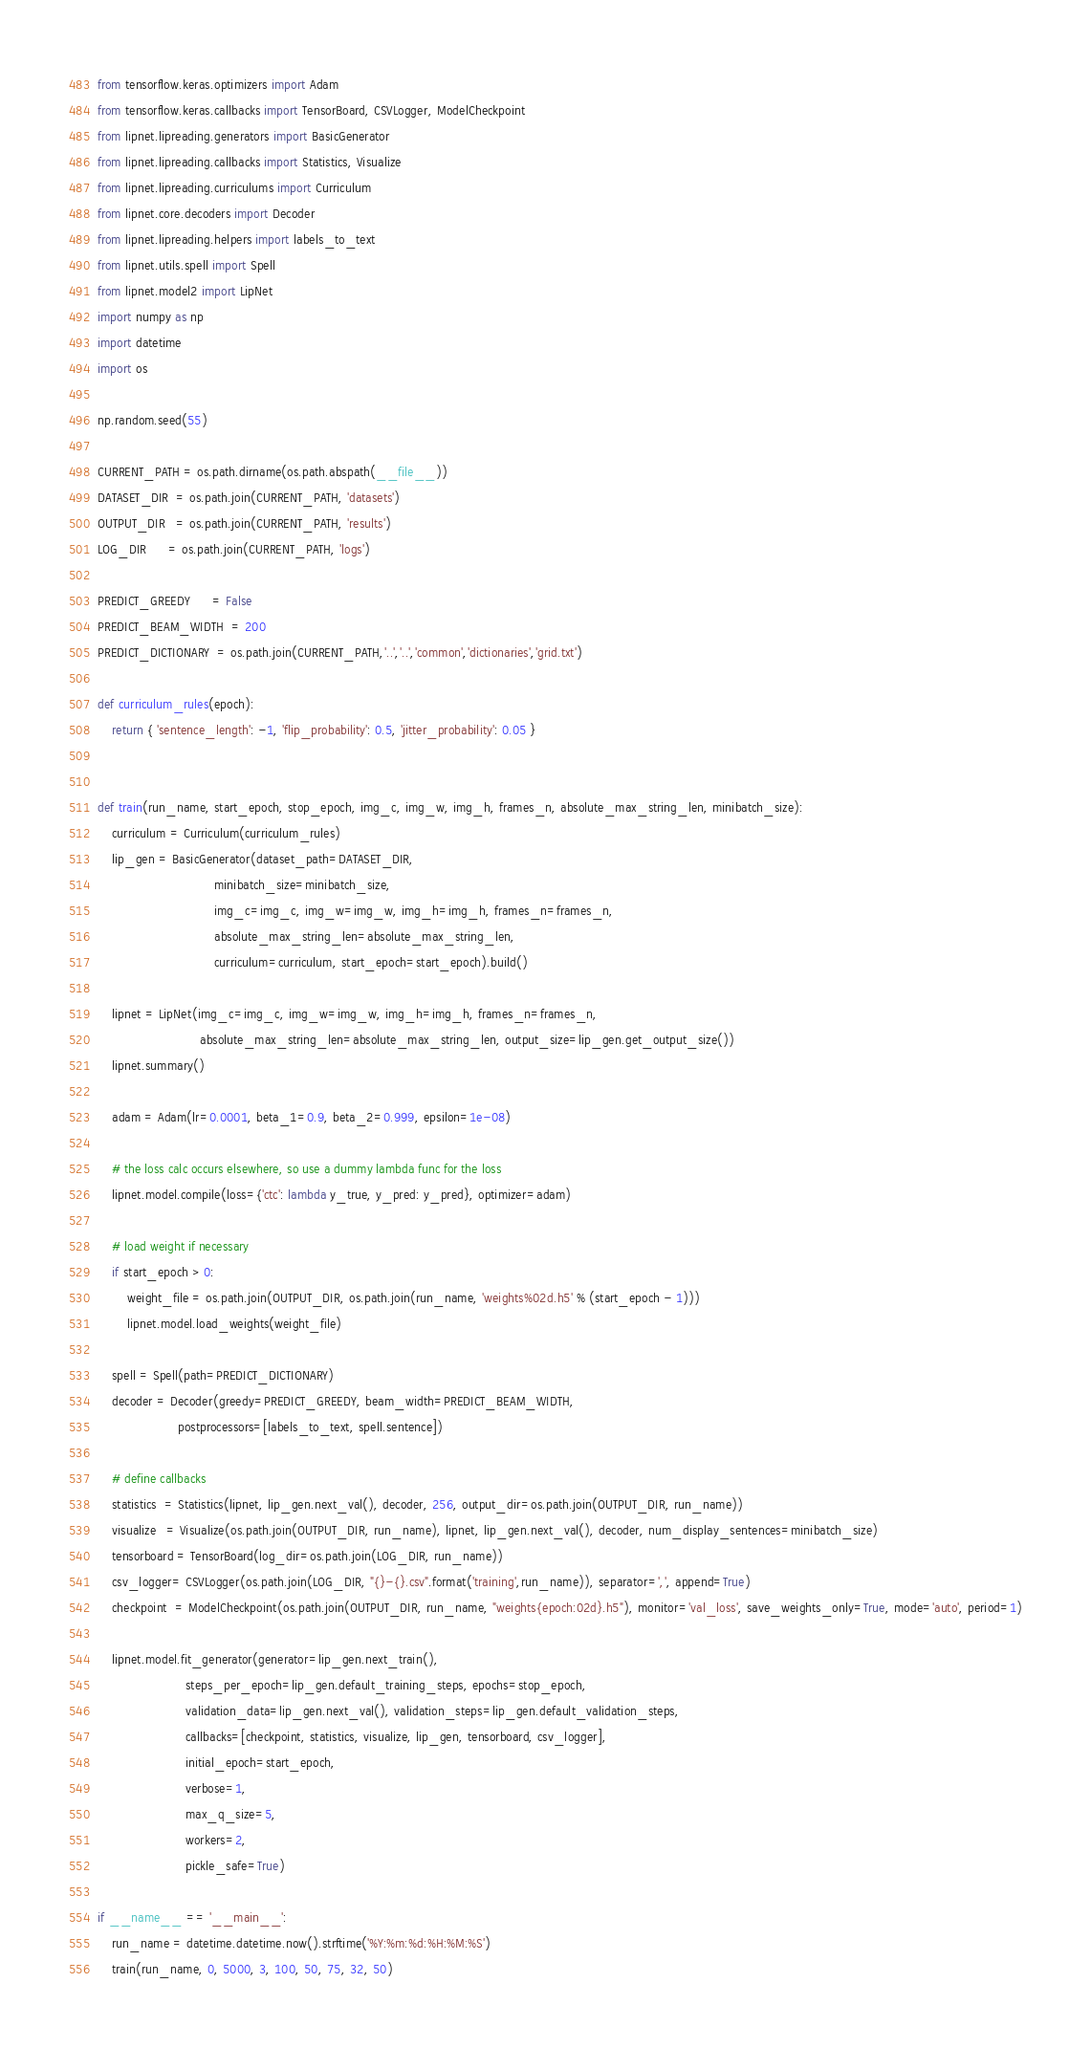<code> <loc_0><loc_0><loc_500><loc_500><_Python_>from tensorflow.keras.optimizers import Adam
from tensorflow.keras.callbacks import TensorBoard, CSVLogger, ModelCheckpoint
from lipnet.lipreading.generators import BasicGenerator
from lipnet.lipreading.callbacks import Statistics, Visualize
from lipnet.lipreading.curriculums import Curriculum
from lipnet.core.decoders import Decoder
from lipnet.lipreading.helpers import labels_to_text
from lipnet.utils.spell import Spell
from lipnet.model2 import LipNet
import numpy as np
import datetime
import os

np.random.seed(55)

CURRENT_PATH = os.path.dirname(os.path.abspath(__file__))
DATASET_DIR  = os.path.join(CURRENT_PATH, 'datasets')
OUTPUT_DIR   = os.path.join(CURRENT_PATH, 'results')
LOG_DIR      = os.path.join(CURRENT_PATH, 'logs')

PREDICT_GREEDY      = False
PREDICT_BEAM_WIDTH  = 200
PREDICT_DICTIONARY  = os.path.join(CURRENT_PATH,'..','..','common','dictionaries','grid.txt')

def curriculum_rules(epoch):
    return { 'sentence_length': -1, 'flip_probability': 0.5, 'jitter_probability': 0.05 }


def train(run_name, start_epoch, stop_epoch, img_c, img_w, img_h, frames_n, absolute_max_string_len, minibatch_size):
    curriculum = Curriculum(curriculum_rules)
    lip_gen = BasicGenerator(dataset_path=DATASET_DIR,
                                minibatch_size=minibatch_size,
                                img_c=img_c, img_w=img_w, img_h=img_h, frames_n=frames_n,
                                absolute_max_string_len=absolute_max_string_len,
                                curriculum=curriculum, start_epoch=start_epoch).build()

    lipnet = LipNet(img_c=img_c, img_w=img_w, img_h=img_h, frames_n=frames_n,
                            absolute_max_string_len=absolute_max_string_len, output_size=lip_gen.get_output_size())
    lipnet.summary()

    adam = Adam(lr=0.0001, beta_1=0.9, beta_2=0.999, epsilon=1e-08)

    # the loss calc occurs elsewhere, so use a dummy lambda func for the loss
    lipnet.model.compile(loss={'ctc': lambda y_true, y_pred: y_pred}, optimizer=adam)

    # load weight if necessary
    if start_epoch > 0:
        weight_file = os.path.join(OUTPUT_DIR, os.path.join(run_name, 'weights%02d.h5' % (start_epoch - 1)))
        lipnet.model.load_weights(weight_file)

    spell = Spell(path=PREDICT_DICTIONARY)
    decoder = Decoder(greedy=PREDICT_GREEDY, beam_width=PREDICT_BEAM_WIDTH,
                      postprocessors=[labels_to_text, spell.sentence])

    # define callbacks
    statistics  = Statistics(lipnet, lip_gen.next_val(), decoder, 256, output_dir=os.path.join(OUTPUT_DIR, run_name))
    visualize   = Visualize(os.path.join(OUTPUT_DIR, run_name), lipnet, lip_gen.next_val(), decoder, num_display_sentences=minibatch_size)
    tensorboard = TensorBoard(log_dir=os.path.join(LOG_DIR, run_name))
    csv_logger= CSVLogger(os.path.join(LOG_DIR, "{}-{}.csv".format('training',run_name)), separator=',', append=True)
    checkpoint  = ModelCheckpoint(os.path.join(OUTPUT_DIR, run_name, "weights{epoch:02d}.h5"), monitor='val_loss', save_weights_only=True, mode='auto', period=1)

    lipnet.model.fit_generator(generator=lip_gen.next_train(),
                        steps_per_epoch=lip_gen.default_training_steps, epochs=stop_epoch,
                        validation_data=lip_gen.next_val(), validation_steps=lip_gen.default_validation_steps,
                        callbacks=[checkpoint, statistics, visualize, lip_gen, tensorboard, csv_logger], 
                        initial_epoch=start_epoch, 
                        verbose=1,
                        max_q_size=5,
                        workers=2,
                        pickle_safe=True)

if __name__ == '__main__':
    run_name = datetime.datetime.now().strftime('%Y:%m:%d:%H:%M:%S')
    train(run_name, 0, 5000, 3, 100, 50, 75, 32, 50)
</code> 